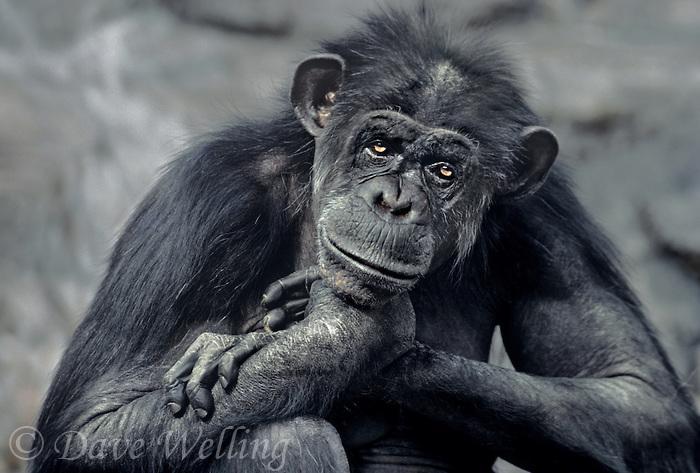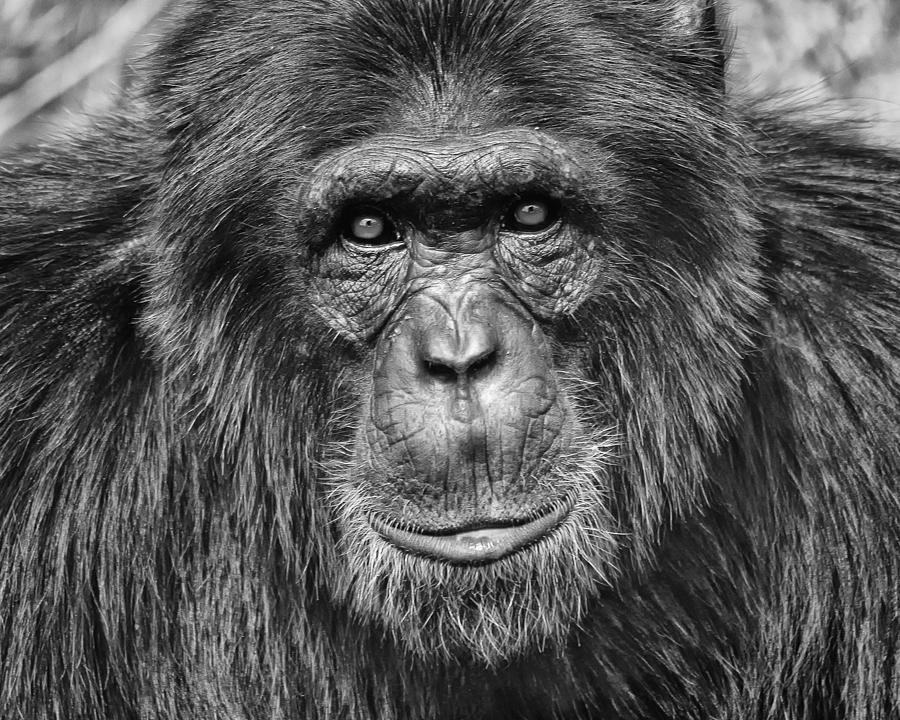The first image is the image on the left, the second image is the image on the right. Considering the images on both sides, is "At least one of the primates is smoking." valid? Answer yes or no. No. 